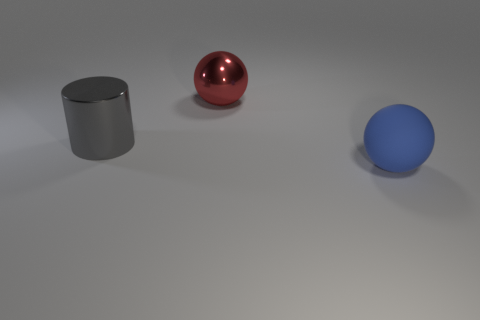Add 3 cyan metal cylinders. How many objects exist? 6 Subtract all balls. How many objects are left? 1 Add 3 large rubber balls. How many large rubber balls exist? 4 Subtract 0 brown cylinders. How many objects are left? 3 Subtract all large red objects. Subtract all rubber things. How many objects are left? 1 Add 1 gray metal cylinders. How many gray metal cylinders are left? 2 